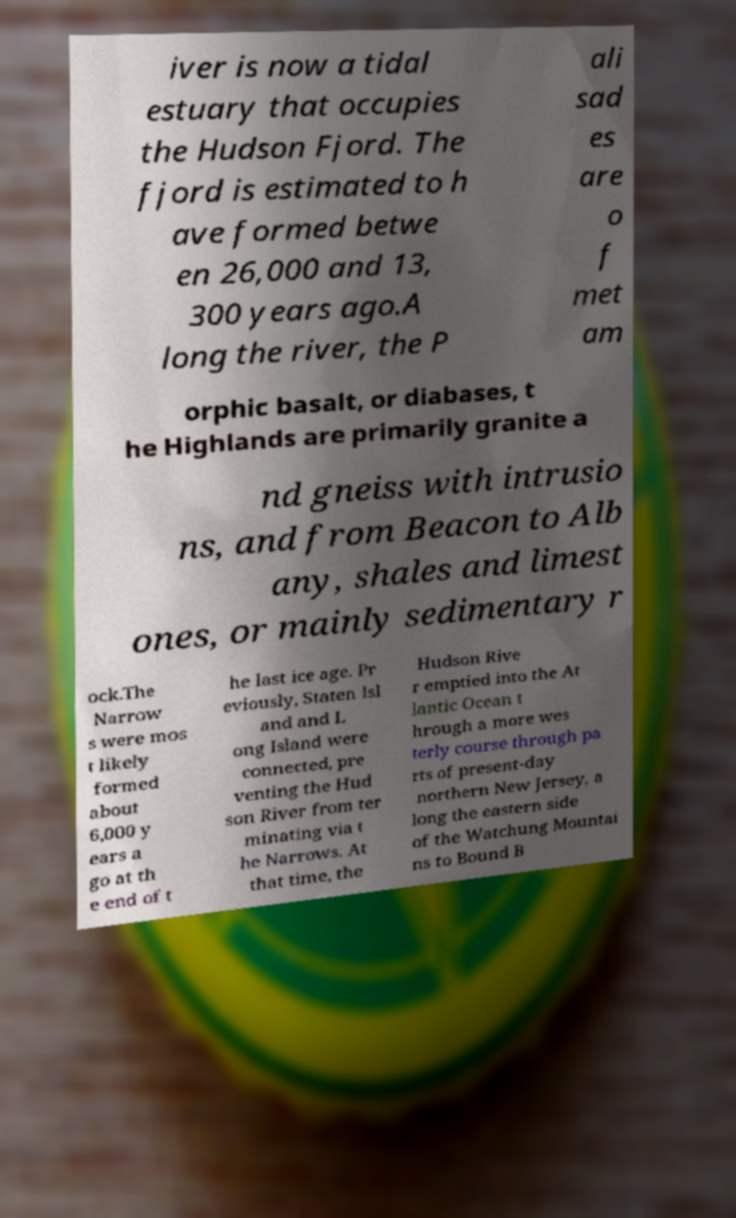For documentation purposes, I need the text within this image transcribed. Could you provide that? iver is now a tidal estuary that occupies the Hudson Fjord. The fjord is estimated to h ave formed betwe en 26,000 and 13, 300 years ago.A long the river, the P ali sad es are o f met am orphic basalt, or diabases, t he Highlands are primarily granite a nd gneiss with intrusio ns, and from Beacon to Alb any, shales and limest ones, or mainly sedimentary r ock.The Narrow s were mos t likely formed about 6,000 y ears a go at th e end of t he last ice age. Pr eviously, Staten Isl and and L ong Island were connected, pre venting the Hud son River from ter minating via t he Narrows. At that time, the Hudson Rive r emptied into the At lantic Ocean t hrough a more wes terly course through pa rts of present-day northern New Jersey, a long the eastern side of the Watchung Mountai ns to Bound B 